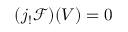Convert formula to latex. <formula><loc_0><loc_0><loc_500><loc_500>( j _ { ! } { \mathcal { F } } ) ( V ) = 0</formula> 